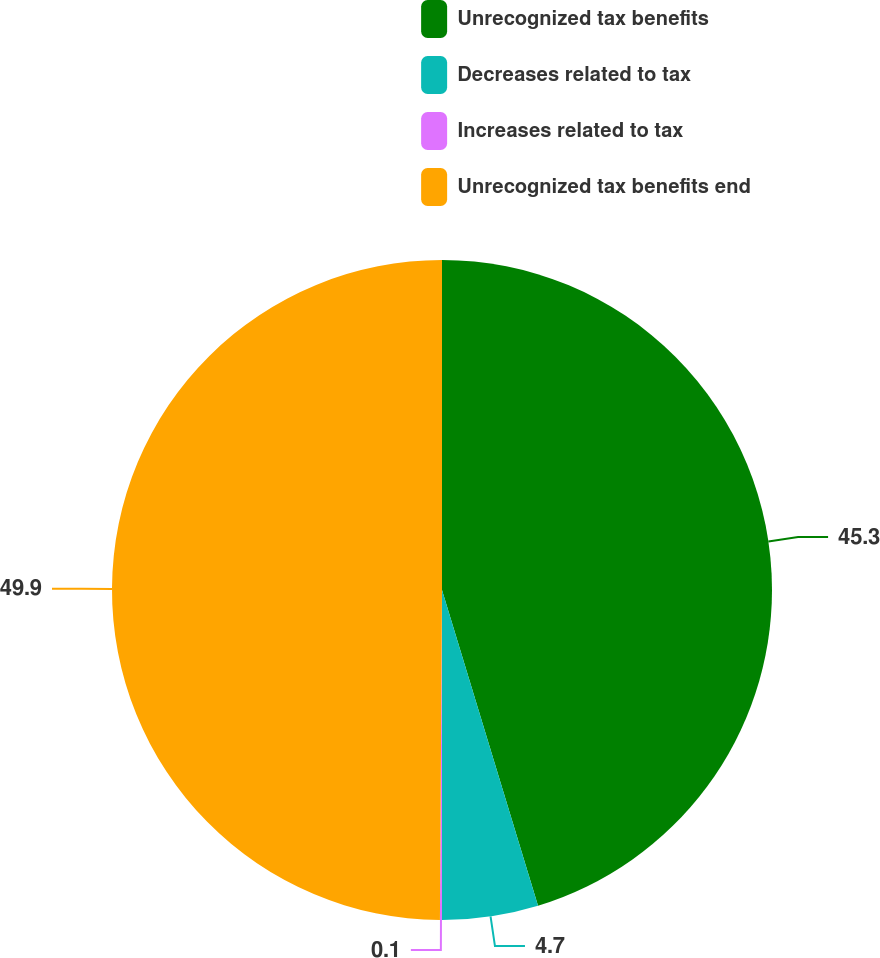Convert chart to OTSL. <chart><loc_0><loc_0><loc_500><loc_500><pie_chart><fcel>Unrecognized tax benefits<fcel>Decreases related to tax<fcel>Increases related to tax<fcel>Unrecognized tax benefits end<nl><fcel>45.3%<fcel>4.7%<fcel>0.1%<fcel>49.9%<nl></chart> 